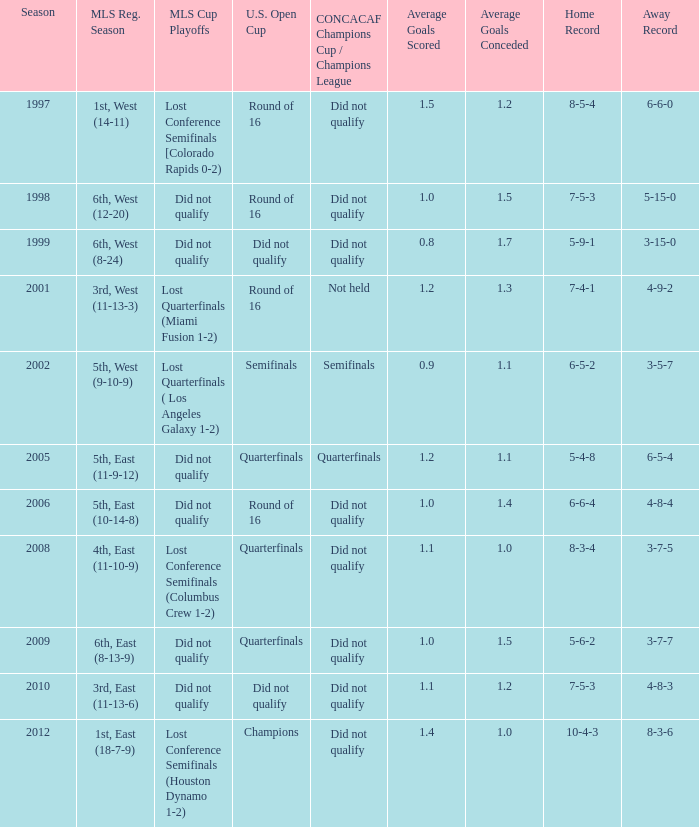Write the full table. {'header': ['Season', 'MLS Reg. Season', 'MLS Cup Playoffs', 'U.S. Open Cup', 'CONCACAF Champions Cup / Champions League', 'Average Goals Scored', 'Average Goals Conceded', 'Home Record', 'Away Record'], 'rows': [['1997', '1st, West (14-11)', 'Lost Conference Semifinals [Colorado Rapids 0-2)', 'Round of 16', 'Did not qualify', '1.5', '1.2', '8-5-4', '6-6-0'], ['1998', '6th, West (12-20)', 'Did not qualify', 'Round of 16', 'Did not qualify', '1.0', '1.5', '7-5-3', '5-15-0'], ['1999', '6th, West (8-24)', 'Did not qualify', 'Did not qualify', 'Did not qualify', '0.8', '1.7', '5-9-1', '3-15-0'], ['2001', '3rd, West (11-13-3)', 'Lost Quarterfinals (Miami Fusion 1-2)', 'Round of 16', 'Not held', '1.2', '1.3', '7-4-1', '4-9-2'], ['2002', '5th, West (9-10-9)', 'Lost Quarterfinals ( Los Angeles Galaxy 1-2)', 'Semifinals', 'Semifinals', '0.9', '1.1', '6-5-2', '3-5-7'], ['2005', '5th, East (11-9-12)', 'Did not qualify', 'Quarterfinals', 'Quarterfinals', '1.2', '1.1', '5-4-8', '6-5-4'], ['2006', '5th, East (10-14-8)', 'Did not qualify', 'Round of 16', 'Did not qualify', '1.0', '1.4', '6-6-4', '4-8-4'], ['2008', '4th, East (11-10-9)', 'Lost Conference Semifinals (Columbus Crew 1-2)', 'Quarterfinals', 'Did not qualify', '1.1', '1.0', '8-3-4', '3-7-5'], ['2009', '6th, East (8-13-9)', 'Did not qualify', 'Quarterfinals', 'Did not qualify', '1.0', '1.5', '5-6-2', '3-7-7'], ['2010', '3rd, East (11-13-6)', 'Did not qualify', 'Did not qualify', 'Did not qualify', '1.1', '1.2', '7-5-3', '4-8-3'], ['2012', '1st, East (18-7-9)', 'Lost Conference Semifinals (Houston Dynamo 1-2)', 'Champions', 'Did not qualify', '1.4', '1.0', '10-4-3', '8-3-6']]} When was the first season? 1997.0. 